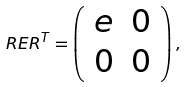Convert formula to latex. <formula><loc_0><loc_0><loc_500><loc_500>R E R ^ { T } = \left ( \begin{array} { c c } e & 0 \\ 0 & 0 \end{array} \right ) ,</formula> 